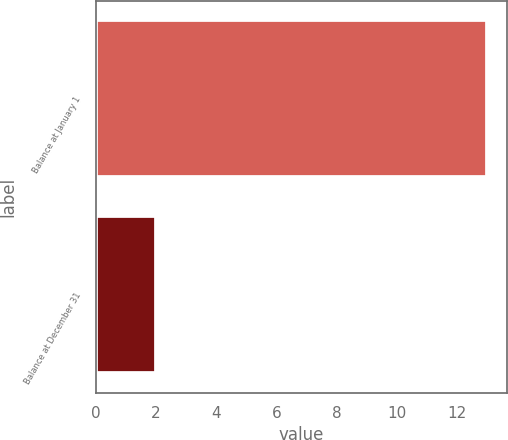Convert chart to OTSL. <chart><loc_0><loc_0><loc_500><loc_500><bar_chart><fcel>Balance at January 1<fcel>Balance at December 31<nl><fcel>13<fcel>2<nl></chart> 